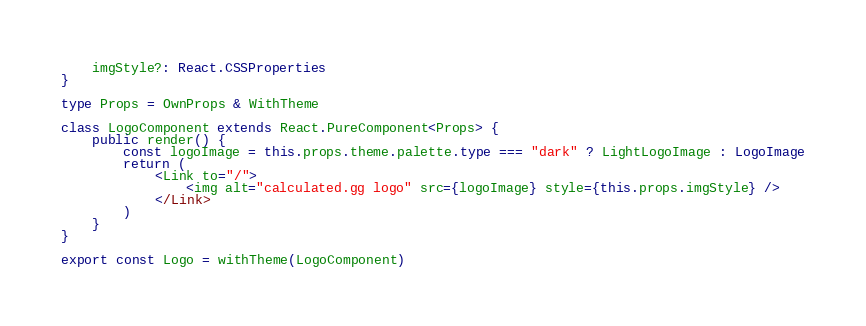<code> <loc_0><loc_0><loc_500><loc_500><_TypeScript_>    imgStyle?: React.CSSProperties
}

type Props = OwnProps & WithTheme

class LogoComponent extends React.PureComponent<Props> {
    public render() {
        const logoImage = this.props.theme.palette.type === "dark" ? LightLogoImage : LogoImage
        return (
            <Link to="/">
                <img alt="calculated.gg logo" src={logoImage} style={this.props.imgStyle} />
            </Link>
        )
    }
}

export const Logo = withTheme(LogoComponent)
</code> 